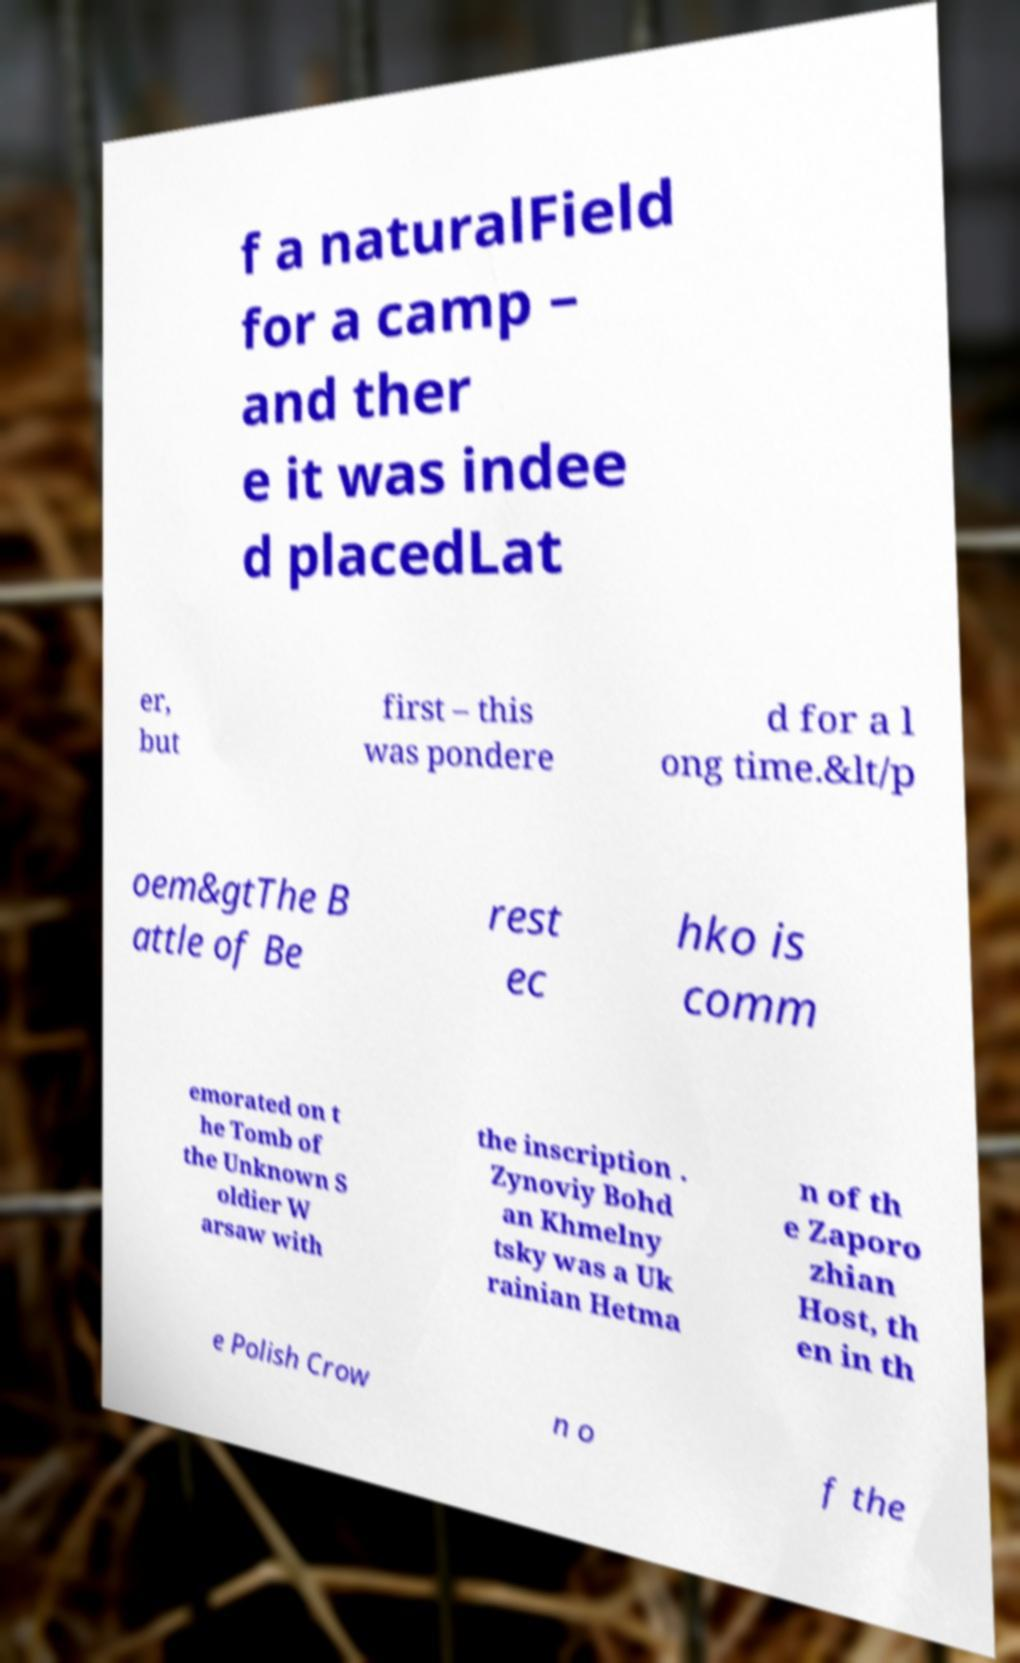Please read and relay the text visible in this image. What does it say? f a naturalField for a camp – and ther e it was indee d placedLat er, but first – this was pondere d for a l ong time.&lt/p oem&gtThe B attle of Be rest ec hko is comm emorated on t he Tomb of the Unknown S oldier W arsaw with the inscription . Zynoviy Bohd an Khmelny tsky was a Uk rainian Hetma n of th e Zaporo zhian Host, th en in th e Polish Crow n o f the 